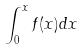Convert formula to latex. <formula><loc_0><loc_0><loc_500><loc_500>\int _ { 0 } ^ { x } f ( x ) d x</formula> 